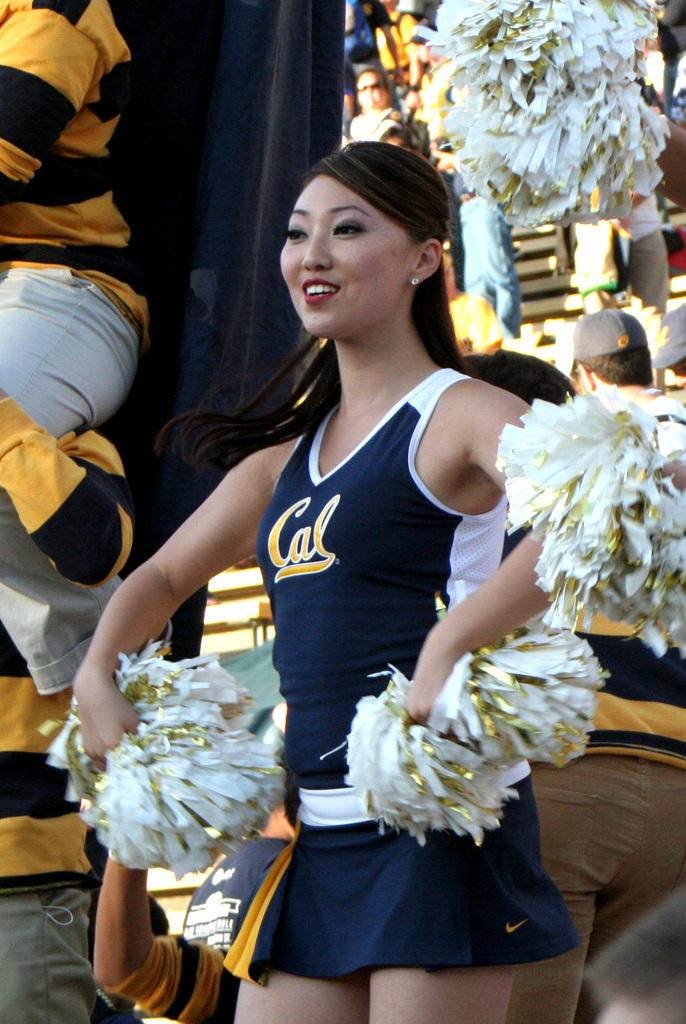What state is this person probably in right now?
Give a very brief answer. California. 